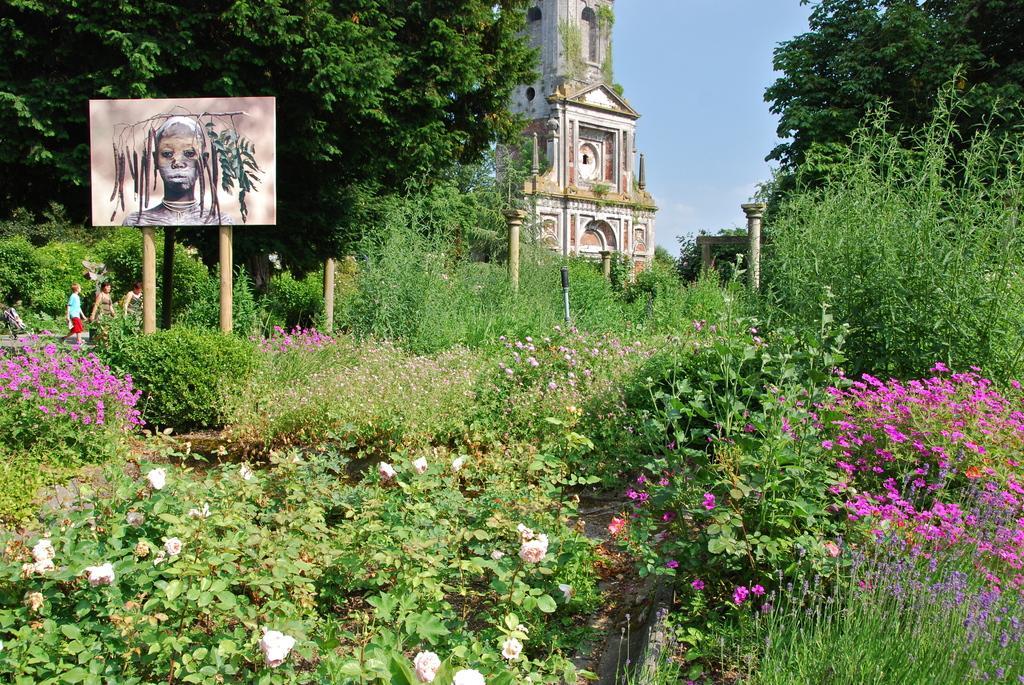In one or two sentences, can you explain what this image depicts? In the left side it is an art and here these are the flower plants. In the middle it looks like a monument. 